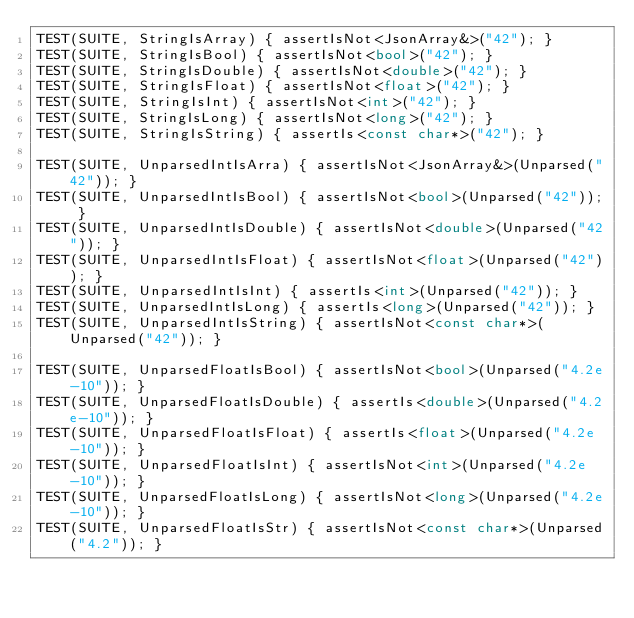Convert code to text. <code><loc_0><loc_0><loc_500><loc_500><_C++_>TEST(SUITE, StringIsArray) { assertIsNot<JsonArray&>("42"); }
TEST(SUITE, StringIsBool) { assertIsNot<bool>("42"); }
TEST(SUITE, StringIsDouble) { assertIsNot<double>("42"); }
TEST(SUITE, StringIsFloat) { assertIsNot<float>("42"); }
TEST(SUITE, StringIsInt) { assertIsNot<int>("42"); }
TEST(SUITE, StringIsLong) { assertIsNot<long>("42"); }
TEST(SUITE, StringIsString) { assertIs<const char*>("42"); }

TEST(SUITE, UnparsedIntIsArra) { assertIsNot<JsonArray&>(Unparsed("42")); }
TEST(SUITE, UnparsedIntIsBool) { assertIsNot<bool>(Unparsed("42")); }
TEST(SUITE, UnparsedIntIsDouble) { assertIsNot<double>(Unparsed("42")); }
TEST(SUITE, UnparsedIntIsFloat) { assertIsNot<float>(Unparsed("42")); }
TEST(SUITE, UnparsedIntIsInt) { assertIs<int>(Unparsed("42")); }
TEST(SUITE, UnparsedIntIsLong) { assertIs<long>(Unparsed("42")); }
TEST(SUITE, UnparsedIntIsString) { assertIsNot<const char*>(Unparsed("42")); }

TEST(SUITE, UnparsedFloatIsBool) { assertIsNot<bool>(Unparsed("4.2e-10")); }
TEST(SUITE, UnparsedFloatIsDouble) { assertIs<double>(Unparsed("4.2e-10")); }
TEST(SUITE, UnparsedFloatIsFloat) { assertIs<float>(Unparsed("4.2e-10")); }
TEST(SUITE, UnparsedFloatIsInt) { assertIsNot<int>(Unparsed("4.2e-10")); }
TEST(SUITE, UnparsedFloatIsLong) { assertIsNot<long>(Unparsed("4.2e-10")); }
TEST(SUITE, UnparsedFloatIsStr) { assertIsNot<const char*>(Unparsed("4.2")); }
</code> 